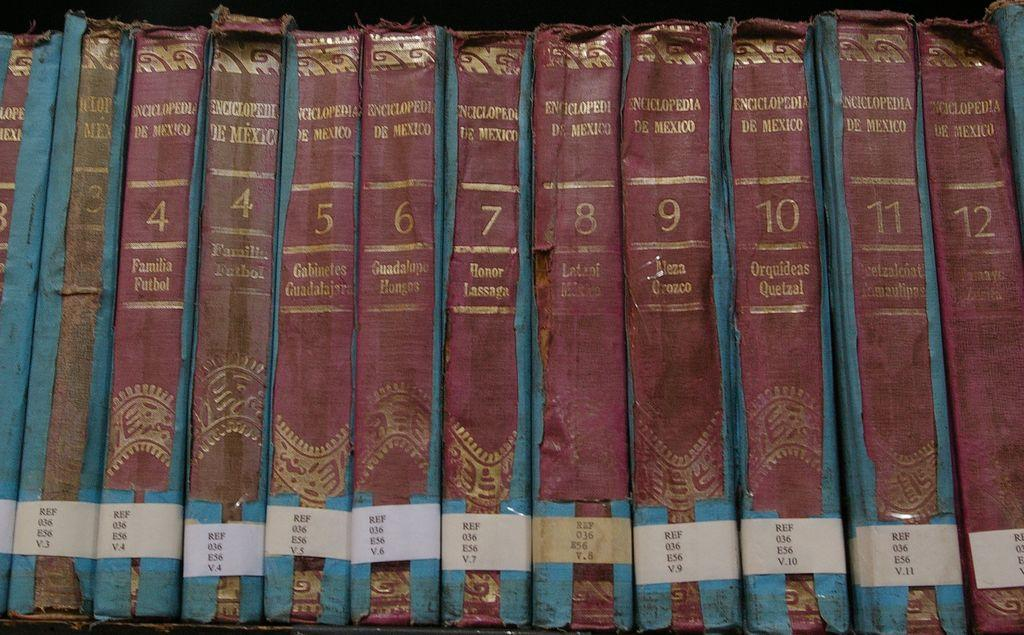<image>
Give a short and clear explanation of the subsequent image. A set of very run down and decayed encyclopedias numbered beteen four and twelve. 